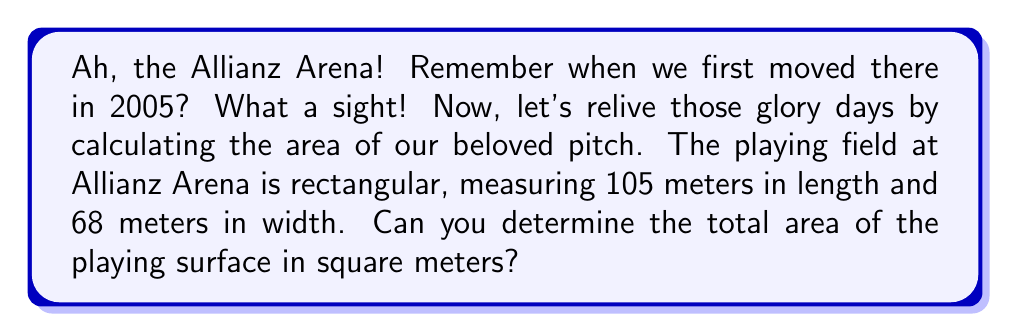Help me with this question. To find the area of the rectangular playing field at Allianz Arena, we need to use the formula for the area of a rectangle:

$$A = l \times w$$

Where:
$A$ = Area
$l$ = Length
$w$ = Width

Given:
Length of the field ($l$) = 105 meters
Width of the field ($w$) = 68 meters

Let's substitute these values into our formula:

$$A = 105 \times 68$$

Now, let's perform the multiplication:

$$A = 7,140$$

Therefore, the area of the playing field is 7,140 square meters.

[asy]
unitsize(0.05cm);
draw((0,0)--(105,0)--(105,68)--(0,68)--cycle);
label("105 m", (52.5,-5));
label("68 m", (-5,34), W);
label("Allianz Arena Field", (52.5,34));
[/asy]
Answer: The area of Bayern Munich's Allianz Arena field is 7,140 square meters. 